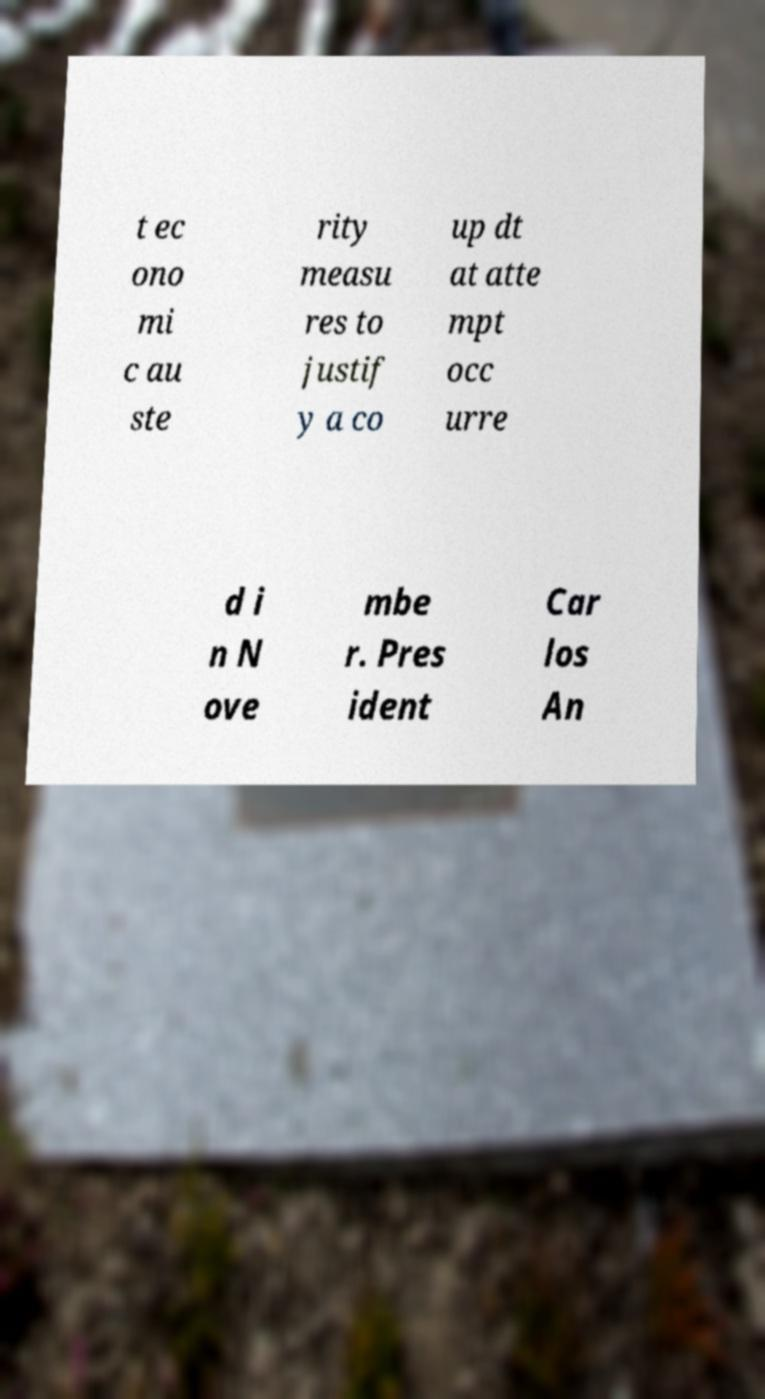Can you read and provide the text displayed in the image?This photo seems to have some interesting text. Can you extract and type it out for me? t ec ono mi c au ste rity measu res to justif y a co up dt at atte mpt occ urre d i n N ove mbe r. Pres ident Car los An 